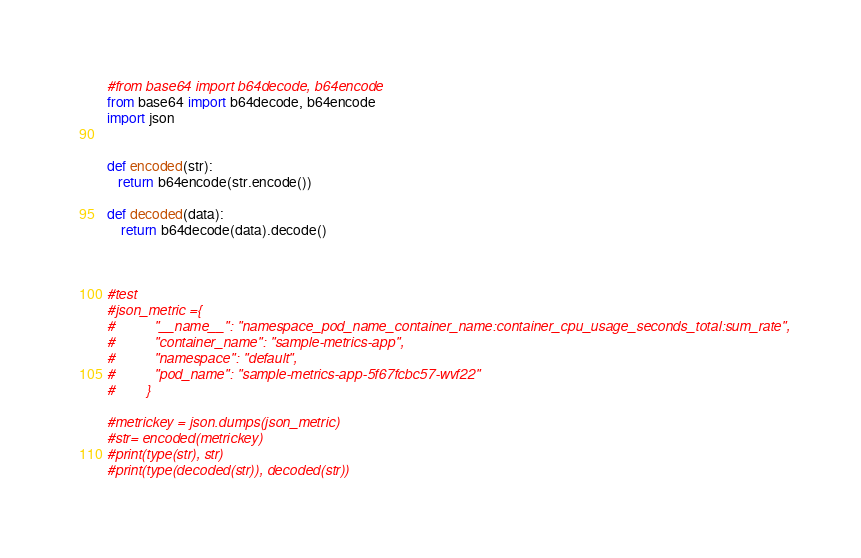<code> <loc_0><loc_0><loc_500><loc_500><_Python_>#from base64 import b64decode, b64encode
from base64 import b64decode, b64encode
import json


def encoded(str):
   return b64encode(str.encode())
    
def decoded(data):
    return b64decode(data).decode()



#test
#json_metric ={
#          "__name__": "namespace_pod_name_container_name:container_cpu_usage_seconds_total:sum_rate",
#          "container_name": "sample-metrics-app",
#          "namespace": "default",
#          "pod_name": "sample-metrics-app-5f67fcbc57-wvf22"
#        }

#metrickey = json.dumps(json_metric)
#str= encoded(metrickey)
#print(type(str), str)  
#print(type(decoded(str)), decoded(str)) 

</code> 